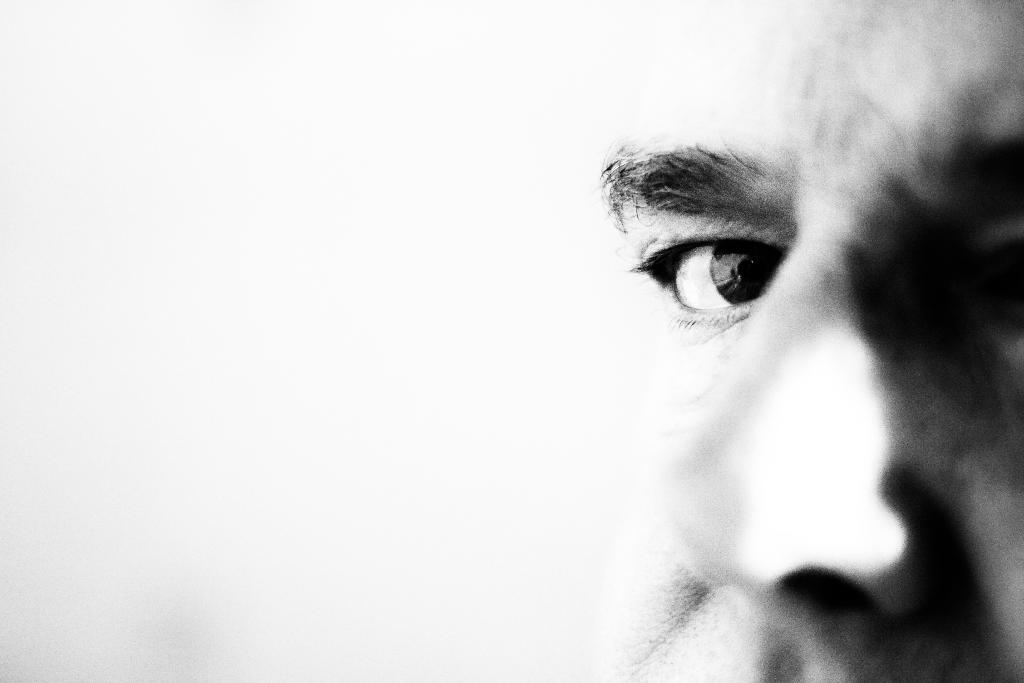Who is present in the image? There is a man in the image. Where is the man located in the image? The man is on the right side of the image. What facial features are visible in the image? The image shows the eye, eyebrows, and nose of a person. What is on the left side of the image? There is a white surface on the left side of the image. How is the white surface depicted in the image? The white surface is blurred. What type of earthquake can be seen in the image? There is no earthquake present in the image. What verse is being recited by the person in the image? There is no verse being recited in the image, as it only shows the eye, eyebrows, and nose of a person. 